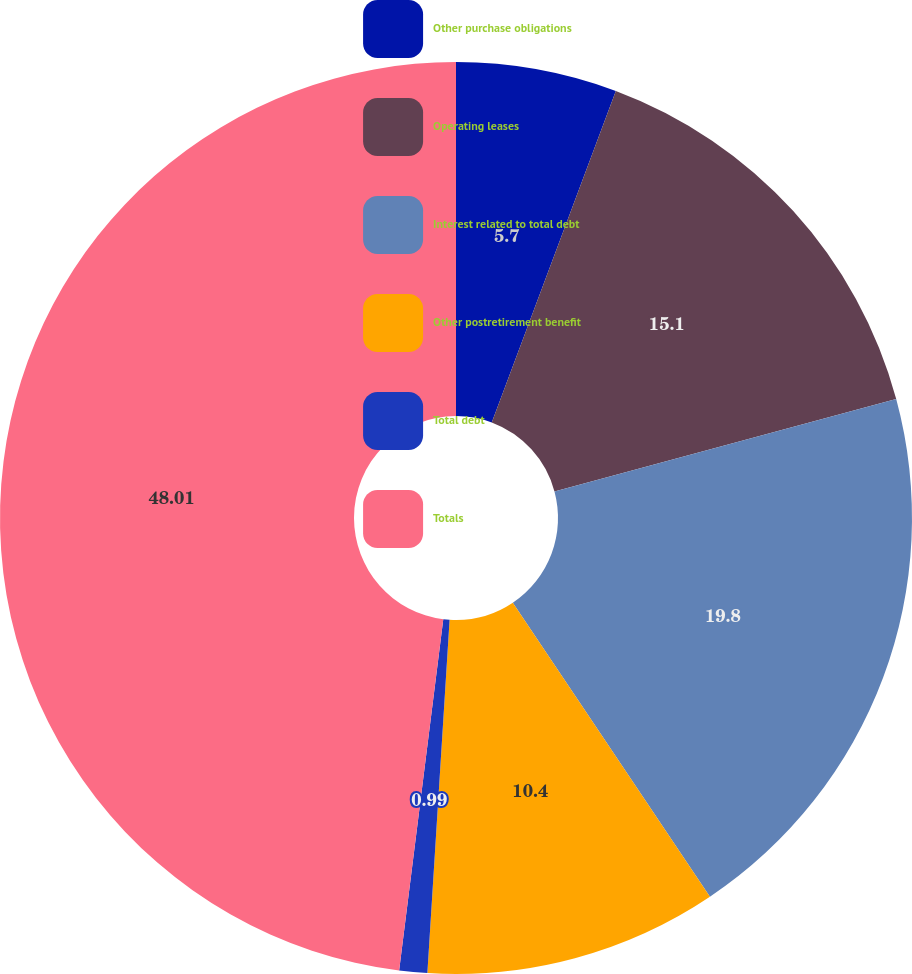Convert chart to OTSL. <chart><loc_0><loc_0><loc_500><loc_500><pie_chart><fcel>Other purchase obligations<fcel>Operating leases<fcel>Interest related to total debt<fcel>Other postretirement benefit<fcel>Total debt<fcel>Totals<nl><fcel>5.7%<fcel>15.1%<fcel>19.8%<fcel>10.4%<fcel>0.99%<fcel>48.01%<nl></chart> 